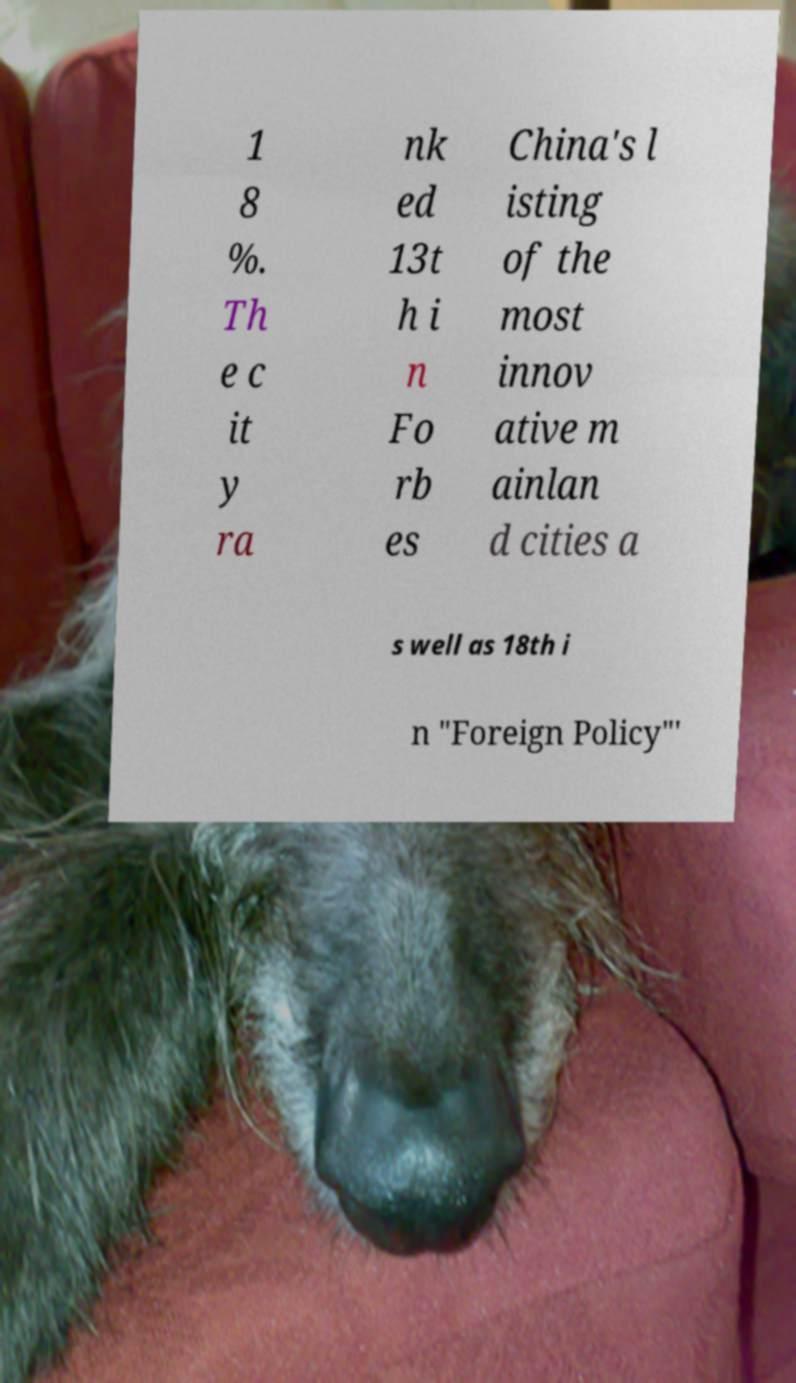Please identify and transcribe the text found in this image. 1 8 %. Th e c it y ra nk ed 13t h i n Fo rb es China's l isting of the most innov ative m ainlan d cities a s well as 18th i n "Foreign Policy"' 